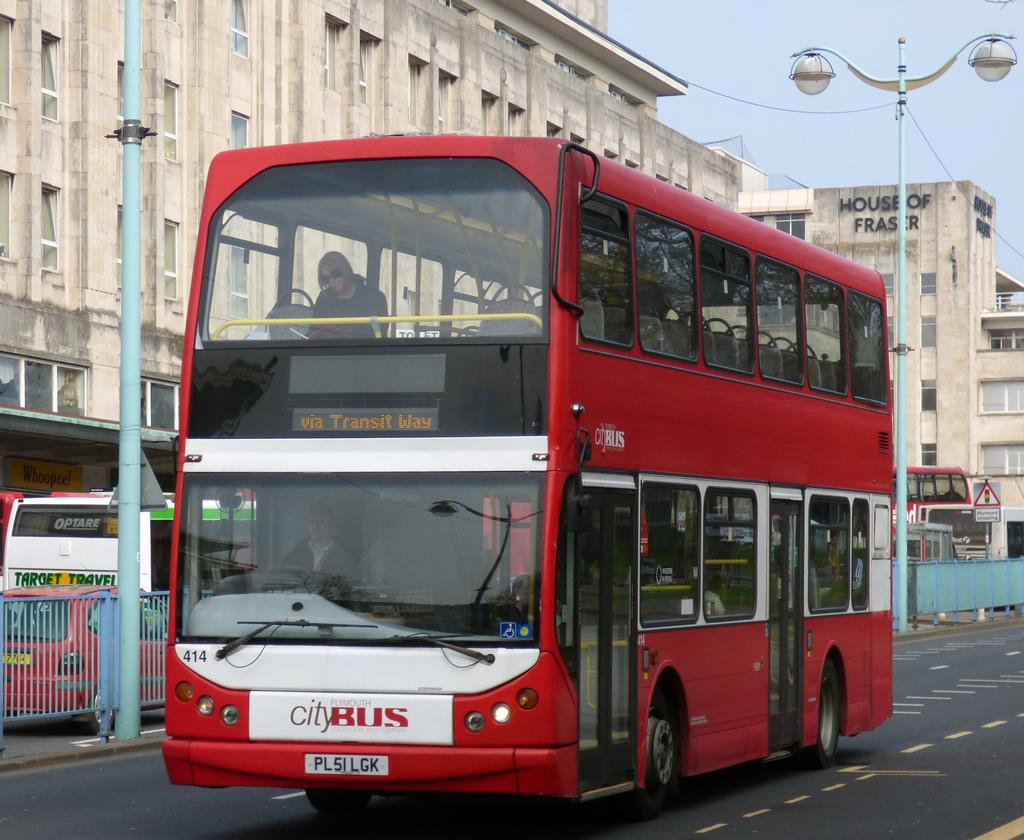<image>
Present a compact description of the photo's key features. A red two decker bus called city bus is driving through the street. 